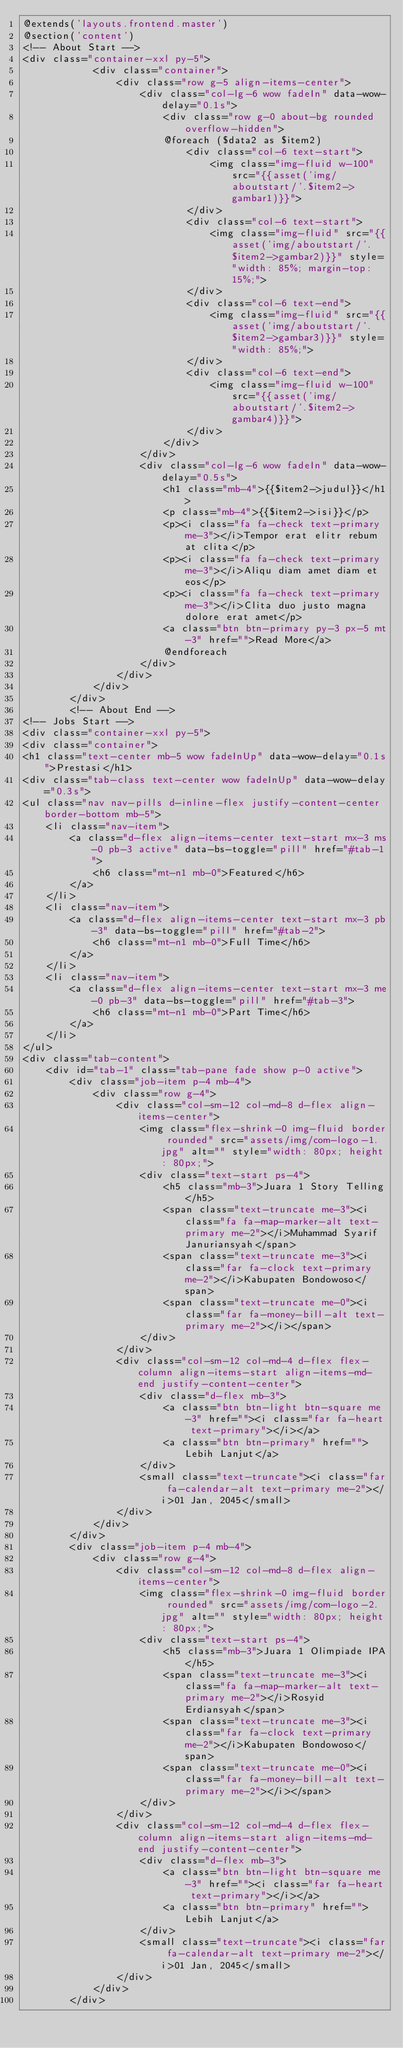Convert code to text. <code><loc_0><loc_0><loc_500><loc_500><_PHP_>@extends('layouts.frontend.master')
@section('content')
<!-- About Start -->
<div class="container-xxl py-5">
            <div class="container">
                <div class="row g-5 align-items-center">
                    <div class="col-lg-6 wow fadeIn" data-wow-delay="0.1s">
                        <div class="row g-0 about-bg rounded overflow-hidden">
                        @foreach ($data2 as $item2)
                            <div class="col-6 text-start">
                                <img class="img-fluid w-100" src="{{asset('img/aboutstart/'.$item2->gambar1)}}">
                            </div>
                            <div class="col-6 text-start">
                                <img class="img-fluid" src="{{asset('img/aboutstart/'.$item2->gambar2)}}" style="width: 85%; margin-top: 15%;">
                            </div>
                            <div class="col-6 text-end">
                                <img class="img-fluid" src="{{asset('img/aboutstart/'.$item2->gambar3)}}" style="width: 85%;">
                            </div>
                            <div class="col-6 text-end">
                                <img class="img-fluid w-100" src="{{asset('img/aboutstart/'.$item2->gambar4)}}">
                            </div>
                        </div>
                    </div>
                    <div class="col-lg-6 wow fadeIn" data-wow-delay="0.5s">
                        <h1 class="mb-4">{{$item2->judul}}</h1>
                        <p class="mb-4">{{$item2->isi}}</p>
                        <p><i class="fa fa-check text-primary me-3"></i>Tempor erat elitr rebum at clita</p>
                        <p><i class="fa fa-check text-primary me-3"></i>Aliqu diam amet diam et eos</p>
                        <p><i class="fa fa-check text-primary me-3"></i>Clita duo justo magna dolore erat amet</p>
                        <a class="btn btn-primary py-3 px-5 mt-3" href="">Read More</a>
                        @endforeach
                    </div>
                </div>
            </div>
        </div>
        <!-- About End -->
<!-- Jobs Start -->
<div class="container-xxl py-5">
<div class="container">
<h1 class="text-center mb-5 wow fadeInUp" data-wow-delay="0.1s">Prestasi</h1>
<div class="tab-class text-center wow fadeInUp" data-wow-delay="0.3s">
<ul class="nav nav-pills d-inline-flex justify-content-center border-bottom mb-5">
    <li class="nav-item">
        <a class="d-flex align-items-center text-start mx-3 ms-0 pb-3 active" data-bs-toggle="pill" href="#tab-1">
            <h6 class="mt-n1 mb-0">Featured</h6>
        </a>
    </li>
    <li class="nav-item">
        <a class="d-flex align-items-center text-start mx-3 pb-3" data-bs-toggle="pill" href="#tab-2">
            <h6 class="mt-n1 mb-0">Full Time</h6>
        </a>
    </li>
    <li class="nav-item">
        <a class="d-flex align-items-center text-start mx-3 me-0 pb-3" data-bs-toggle="pill" href="#tab-3">
            <h6 class="mt-n1 mb-0">Part Time</h6>
        </a>
    </li>
</ul>
<div class="tab-content">
    <div id="tab-1" class="tab-pane fade show p-0 active">
        <div class="job-item p-4 mb-4">
            <div class="row g-4">
                <div class="col-sm-12 col-md-8 d-flex align-items-center">
                    <img class="flex-shrink-0 img-fluid border rounded" src="assets/img/com-logo-1.jpg" alt="" style="width: 80px; height: 80px;">
                    <div class="text-start ps-4">
                        <h5 class="mb-3">Juara 1 Story Telling</h5>
                        <span class="text-truncate me-3"><i class="fa fa-map-marker-alt text-primary me-2"></i>Muhammad Syarif Januriansyah</span>
                        <span class="text-truncate me-3"><i class="far fa-clock text-primary me-2"></i>Kabupaten Bondowoso</span>
                        <span class="text-truncate me-0"><i class="far fa-money-bill-alt text-primary me-2"></i></span>
                    </div>
                </div>
                <div class="col-sm-12 col-md-4 d-flex flex-column align-items-start align-items-md-end justify-content-center">
                    <div class="d-flex mb-3">
                        <a class="btn btn-light btn-square me-3" href=""><i class="far fa-heart text-primary"></i></a>
                        <a class="btn btn-primary" href="">Lebih Lanjut</a>
                    </div>
                    <small class="text-truncate"><i class="far fa-calendar-alt text-primary me-2"></i>01 Jan, 2045</small>
                </div>
            </div>
        </div>
        <div class="job-item p-4 mb-4">
            <div class="row g-4">
                <div class="col-sm-12 col-md-8 d-flex align-items-center">
                    <img class="flex-shrink-0 img-fluid border rounded" src="assets/img/com-logo-2.jpg" alt="" style="width: 80px; height: 80px;">
                    <div class="text-start ps-4">
                        <h5 class="mb-3">Juara 1 Olimpiade IPA</h5>
                        <span class="text-truncate me-3"><i class="fa fa-map-marker-alt text-primary me-2"></i>Rosyid Erdiansyah</span>
                        <span class="text-truncate me-3"><i class="far fa-clock text-primary me-2"></i>Kabupaten Bondowoso</span>
                        <span class="text-truncate me-0"><i class="far fa-money-bill-alt text-primary me-2"></i></span>
                    </div>
                </div>
                <div class="col-sm-12 col-md-4 d-flex flex-column align-items-start align-items-md-end justify-content-center">
                    <div class="d-flex mb-3">
                        <a class="btn btn-light btn-square me-3" href=""><i class="far fa-heart text-primary"></i></a>
                        <a class="btn btn-primary" href="">Lebih Lanjut</a>
                    </div>
                    <small class="text-truncate"><i class="far fa-calendar-alt text-primary me-2"></i>01 Jan, 2045</small>
                </div>
            </div>
        </div></code> 